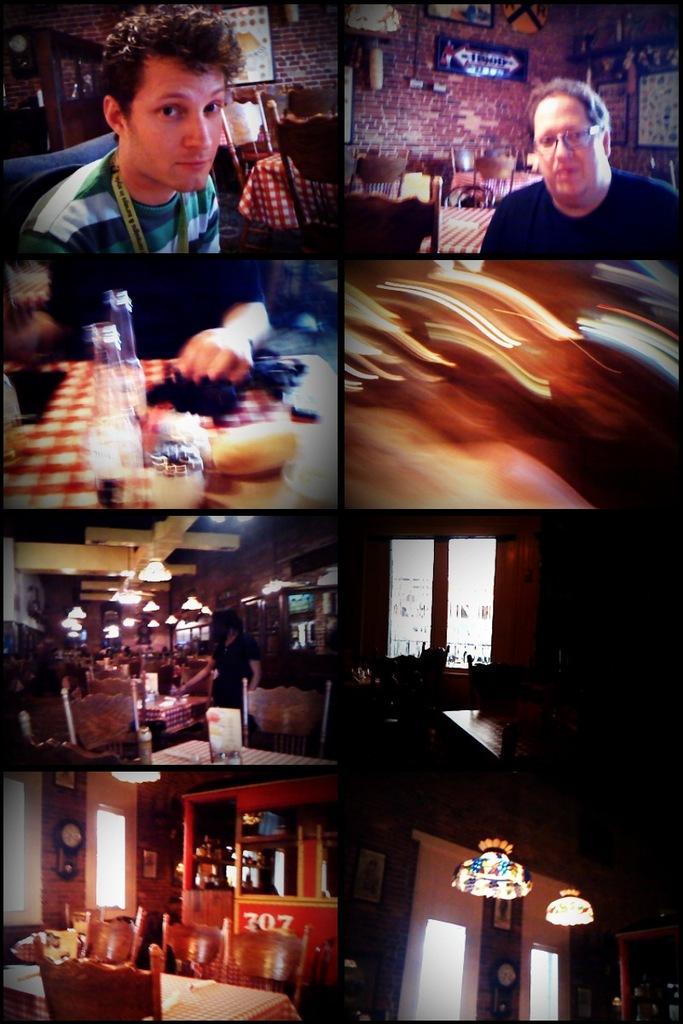How would you summarize this image in a sentence or two? This is a collage in this image there are some persons, tables, chairs, lights, glass windows, wall, clock, calendar and some photo frames on the wall and some other objects. 